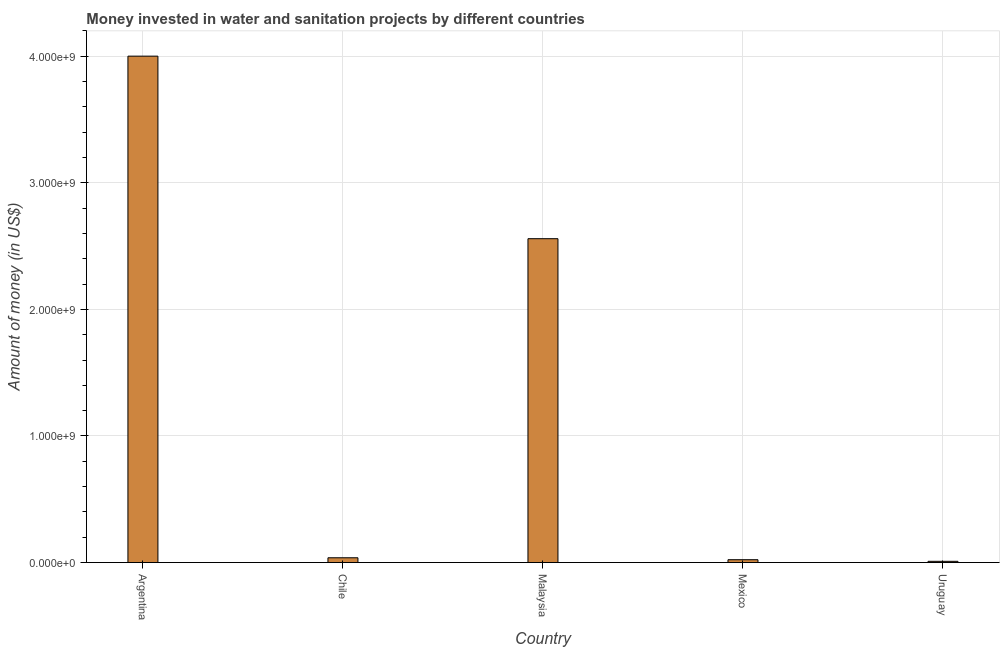Does the graph contain grids?
Offer a terse response. Yes. What is the title of the graph?
Ensure brevity in your answer.  Money invested in water and sanitation projects by different countries. What is the label or title of the Y-axis?
Ensure brevity in your answer.  Amount of money (in US$). What is the investment in Chile?
Your answer should be compact. 3.80e+07. Across all countries, what is the maximum investment?
Ensure brevity in your answer.  4.00e+09. In which country was the investment maximum?
Keep it short and to the point. Argentina. In which country was the investment minimum?
Your response must be concise. Uruguay. What is the sum of the investment?
Make the answer very short. 6.63e+09. What is the difference between the investment in Argentina and Chile?
Your response must be concise. 3.96e+09. What is the average investment per country?
Your response must be concise. 1.33e+09. What is the median investment?
Ensure brevity in your answer.  3.80e+07. In how many countries, is the investment greater than 3800000000 US$?
Your answer should be very brief. 1. What is the ratio of the investment in Malaysia to that in Mexico?
Offer a terse response. 112.2. Is the difference between the investment in Argentina and Chile greater than the difference between any two countries?
Make the answer very short. No. What is the difference between the highest and the second highest investment?
Your response must be concise. 1.44e+09. What is the difference between the highest and the lowest investment?
Ensure brevity in your answer.  3.99e+09. In how many countries, is the investment greater than the average investment taken over all countries?
Offer a terse response. 2. How many bars are there?
Make the answer very short. 5. Are all the bars in the graph horizontal?
Your answer should be compact. No. How many countries are there in the graph?
Provide a short and direct response. 5. What is the Amount of money (in US$) in Argentina?
Your answer should be compact. 4.00e+09. What is the Amount of money (in US$) of Chile?
Give a very brief answer. 3.80e+07. What is the Amount of money (in US$) of Malaysia?
Keep it short and to the point. 2.56e+09. What is the Amount of money (in US$) in Mexico?
Make the answer very short. 2.28e+07. What is the Amount of money (in US$) in Uruguay?
Keep it short and to the point. 1.00e+07. What is the difference between the Amount of money (in US$) in Argentina and Chile?
Give a very brief answer. 3.96e+09. What is the difference between the Amount of money (in US$) in Argentina and Malaysia?
Your answer should be very brief. 1.44e+09. What is the difference between the Amount of money (in US$) in Argentina and Mexico?
Your answer should be compact. 3.98e+09. What is the difference between the Amount of money (in US$) in Argentina and Uruguay?
Your answer should be very brief. 3.99e+09. What is the difference between the Amount of money (in US$) in Chile and Malaysia?
Your answer should be very brief. -2.52e+09. What is the difference between the Amount of money (in US$) in Chile and Mexico?
Provide a succinct answer. 1.52e+07. What is the difference between the Amount of money (in US$) in Chile and Uruguay?
Offer a terse response. 2.80e+07. What is the difference between the Amount of money (in US$) in Malaysia and Mexico?
Keep it short and to the point. 2.54e+09. What is the difference between the Amount of money (in US$) in Malaysia and Uruguay?
Make the answer very short. 2.55e+09. What is the difference between the Amount of money (in US$) in Mexico and Uruguay?
Ensure brevity in your answer.  1.28e+07. What is the ratio of the Amount of money (in US$) in Argentina to that in Chile?
Provide a short and direct response. 105.26. What is the ratio of the Amount of money (in US$) in Argentina to that in Malaysia?
Ensure brevity in your answer.  1.56. What is the ratio of the Amount of money (in US$) in Argentina to that in Mexico?
Keep it short and to the point. 175.44. What is the ratio of the Amount of money (in US$) in Argentina to that in Uruguay?
Give a very brief answer. 400. What is the ratio of the Amount of money (in US$) in Chile to that in Malaysia?
Offer a very short reply. 0.01. What is the ratio of the Amount of money (in US$) in Chile to that in Mexico?
Ensure brevity in your answer.  1.67. What is the ratio of the Amount of money (in US$) in Chile to that in Uruguay?
Provide a succinct answer. 3.8. What is the ratio of the Amount of money (in US$) in Malaysia to that in Mexico?
Keep it short and to the point. 112.2. What is the ratio of the Amount of money (in US$) in Malaysia to that in Uruguay?
Your answer should be compact. 255.82. What is the ratio of the Amount of money (in US$) in Mexico to that in Uruguay?
Offer a very short reply. 2.28. 